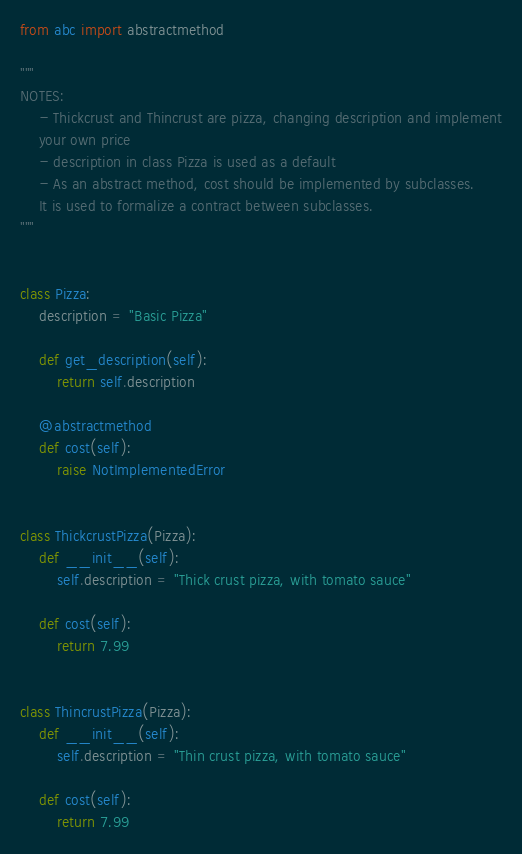Convert code to text. <code><loc_0><loc_0><loc_500><loc_500><_Python_>from abc import abstractmethod

"""
NOTES:
    - Thickcrust and Thincrust are pizza, changing description and implement
    your own price
    - description in class Pizza is used as a default
    - As an abstract method, cost should be implemented by subclasses.
    It is used to formalize a contract between subclasses.
"""


class Pizza:
    description = "Basic Pizza"

    def get_description(self):
        return self.description

    @abstractmethod
    def cost(self):
        raise NotImplementedError


class ThickcrustPizza(Pizza):
    def __init__(self):
        self.description = "Thick crust pizza, with tomato sauce"

    def cost(self):
        return 7.99


class ThincrustPizza(Pizza):
    def __init__(self):
        self.description = "Thin crust pizza, with tomato sauce"

    def cost(self):
        return 7.99
</code> 